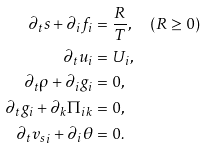<formula> <loc_0><loc_0><loc_500><loc_500>\partial _ { t } s + \partial _ { i } f _ { i } & = \frac { R } { T } , \quad ( R \geq 0 ) \\ \partial _ { t } u _ { i } & = U _ { i } , \\ \partial _ { t } \rho + \partial _ { i } g _ { i } & = 0 , \\ \partial _ { t } g _ { i } + \partial _ { k } \Pi _ { i k } & = 0 , \\ \partial _ { t } { v _ { s } } _ { i } + \partial _ { i } \theta & = 0 .</formula> 